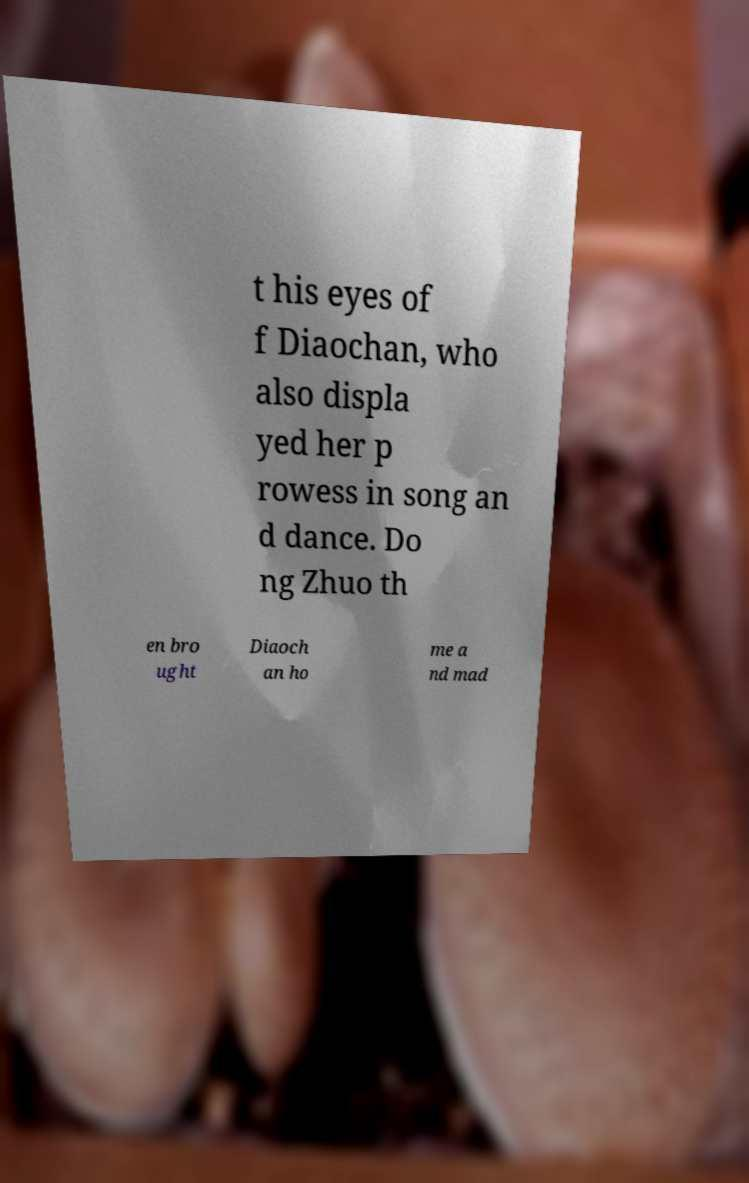I need the written content from this picture converted into text. Can you do that? t his eyes of f Diaochan, who also displa yed her p rowess in song an d dance. Do ng Zhuo th en bro ught Diaoch an ho me a nd mad 